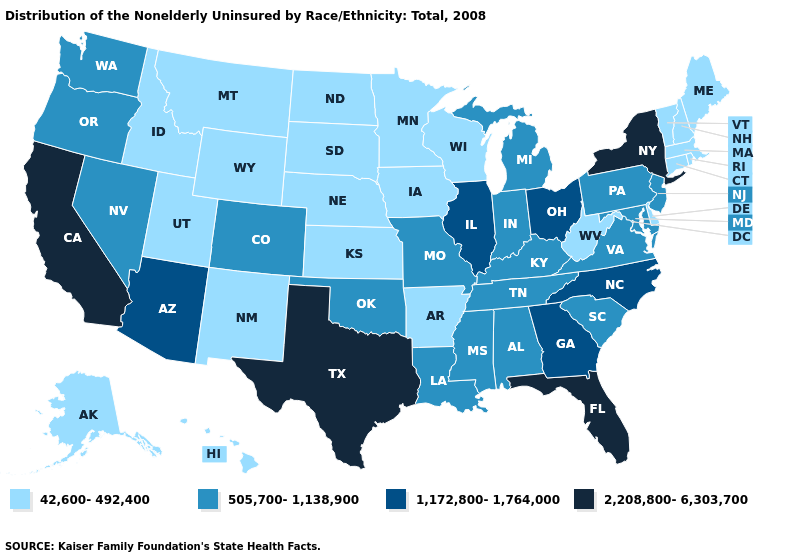What is the value of Indiana?
Answer briefly. 505,700-1,138,900. Does Nebraska have the lowest value in the MidWest?
Be succinct. Yes. Name the states that have a value in the range 1,172,800-1,764,000?
Give a very brief answer. Arizona, Georgia, Illinois, North Carolina, Ohio. Name the states that have a value in the range 42,600-492,400?
Concise answer only. Alaska, Arkansas, Connecticut, Delaware, Hawaii, Idaho, Iowa, Kansas, Maine, Massachusetts, Minnesota, Montana, Nebraska, New Hampshire, New Mexico, North Dakota, Rhode Island, South Dakota, Utah, Vermont, West Virginia, Wisconsin, Wyoming. Name the states that have a value in the range 1,172,800-1,764,000?
Concise answer only. Arizona, Georgia, Illinois, North Carolina, Ohio. Name the states that have a value in the range 1,172,800-1,764,000?
Answer briefly. Arizona, Georgia, Illinois, North Carolina, Ohio. Among the states that border Alabama , does Mississippi have the highest value?
Keep it brief. No. What is the highest value in the South ?
Give a very brief answer. 2,208,800-6,303,700. Does Indiana have a higher value than Arizona?
Be succinct. No. Is the legend a continuous bar?
Concise answer only. No. Name the states that have a value in the range 42,600-492,400?
Short answer required. Alaska, Arkansas, Connecticut, Delaware, Hawaii, Idaho, Iowa, Kansas, Maine, Massachusetts, Minnesota, Montana, Nebraska, New Hampshire, New Mexico, North Dakota, Rhode Island, South Dakota, Utah, Vermont, West Virginia, Wisconsin, Wyoming. What is the highest value in the South ?
Keep it brief. 2,208,800-6,303,700. What is the value of Maine?
Keep it brief. 42,600-492,400. Does the map have missing data?
Quick response, please. No. Among the states that border Oregon , which have the lowest value?
Quick response, please. Idaho. 